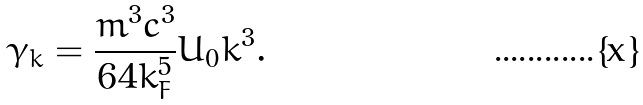<formula> <loc_0><loc_0><loc_500><loc_500>\gamma _ { k } = \frac { m ^ { 3 } c ^ { 3 } } { 6 4 k _ { F } ^ { 5 } } U _ { 0 } k ^ { 3 } .</formula> 